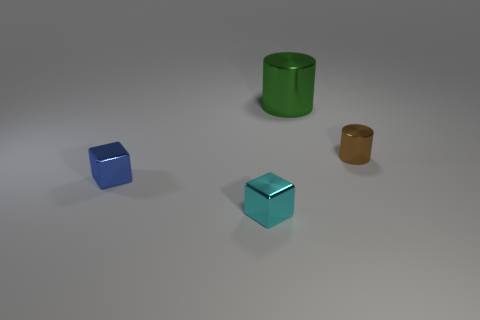Add 1 tiny blue objects. How many objects exist? 5 Subtract all big rubber balls. Subtract all small things. How many objects are left? 1 Add 1 shiny objects. How many shiny objects are left? 5 Add 4 metallic cubes. How many metallic cubes exist? 6 Subtract 0 brown balls. How many objects are left? 4 